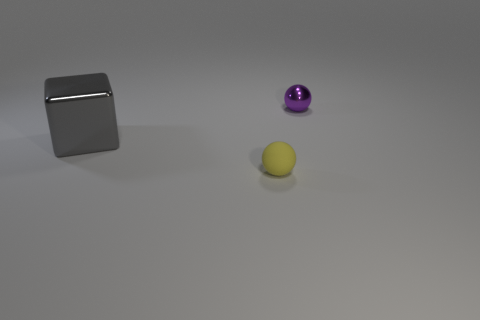Add 3 yellow balls. How many objects exist? 6 Subtract all spheres. How many objects are left? 1 Add 2 yellow objects. How many yellow objects exist? 3 Subtract 1 purple balls. How many objects are left? 2 Subtract all large cyan rubber cubes. Subtract all tiny metallic balls. How many objects are left? 2 Add 1 matte things. How many matte things are left? 2 